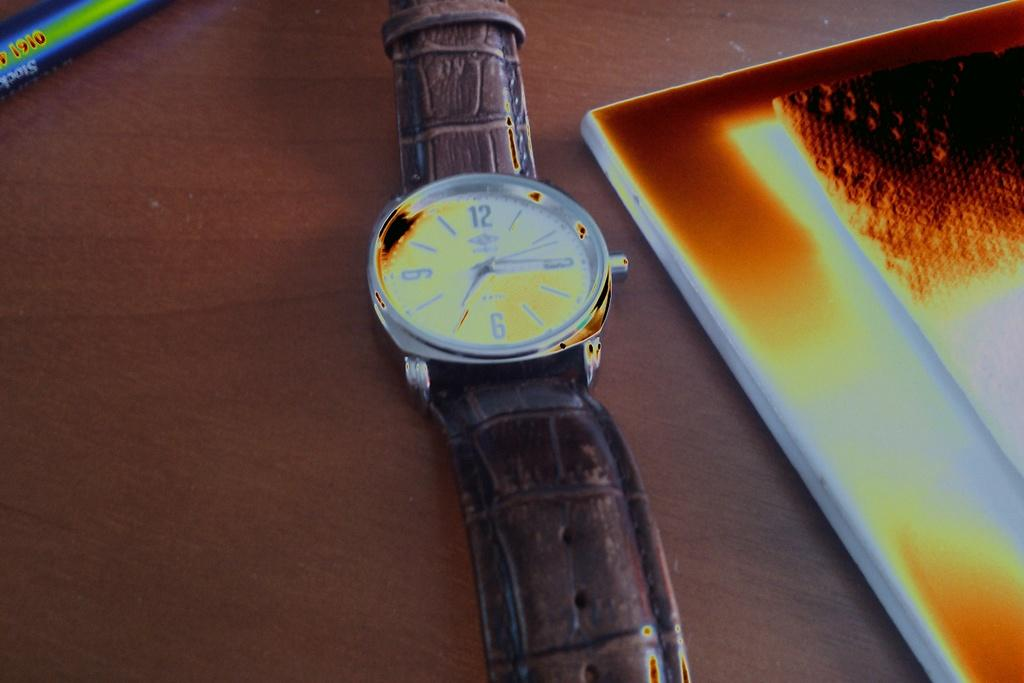<image>
Describe the image concisely. A watch lying on a table next to a picture shows the time as 7:15. 